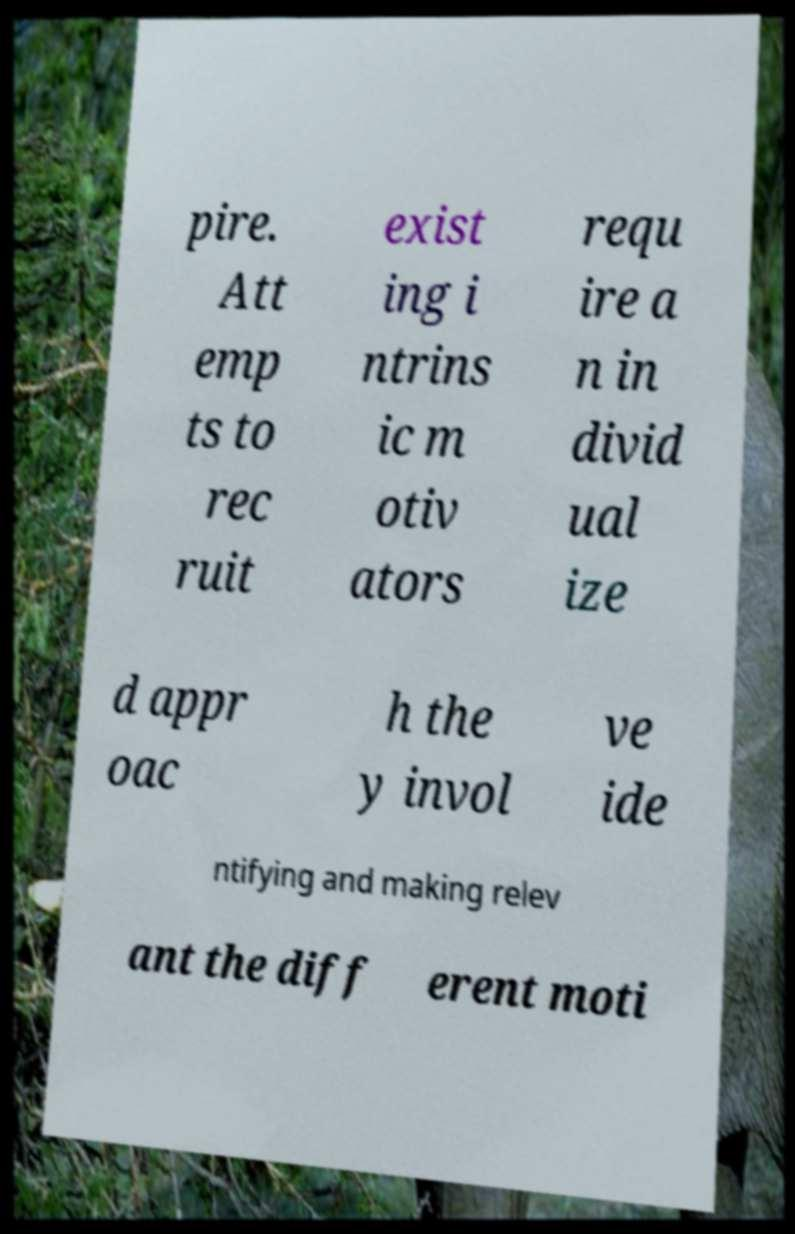Please identify and transcribe the text found in this image. pire. Att emp ts to rec ruit exist ing i ntrins ic m otiv ators requ ire a n in divid ual ize d appr oac h the y invol ve ide ntifying and making relev ant the diff erent moti 